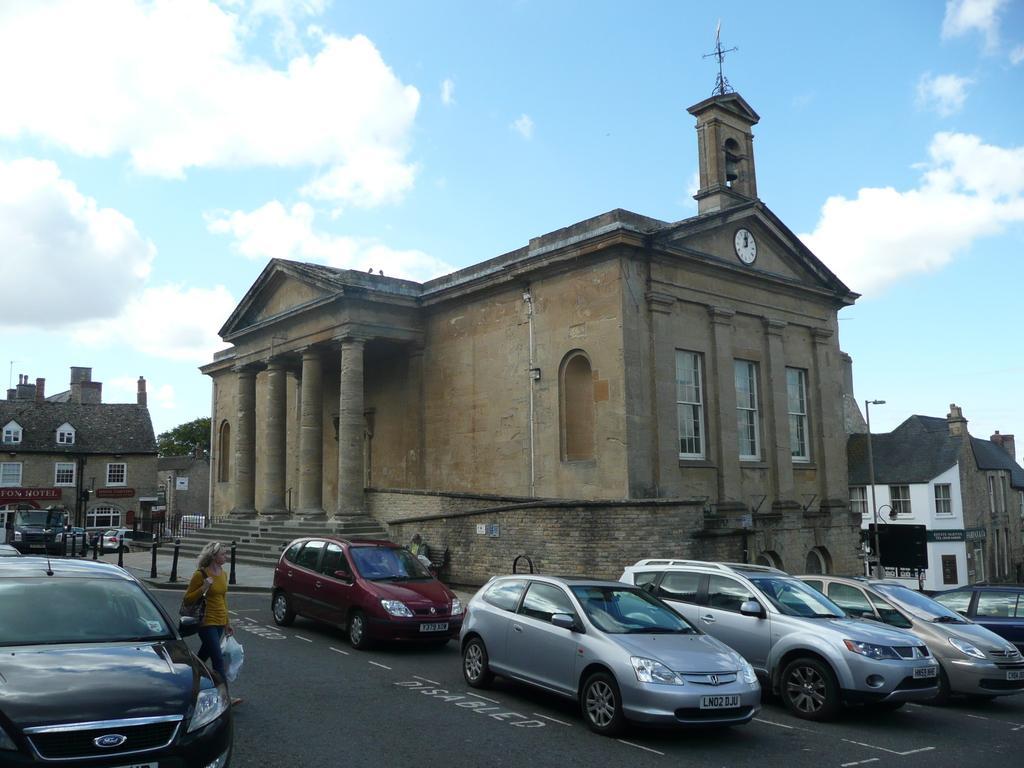Please provide a concise description of this image. In this image in the middle, there are buildings, trees. On the left there is a woman, she wears a t shirt, trouser, bag, she is walking. At the bottom there are cars, sign boards, poles, road. At the top there are sky and clouds. 